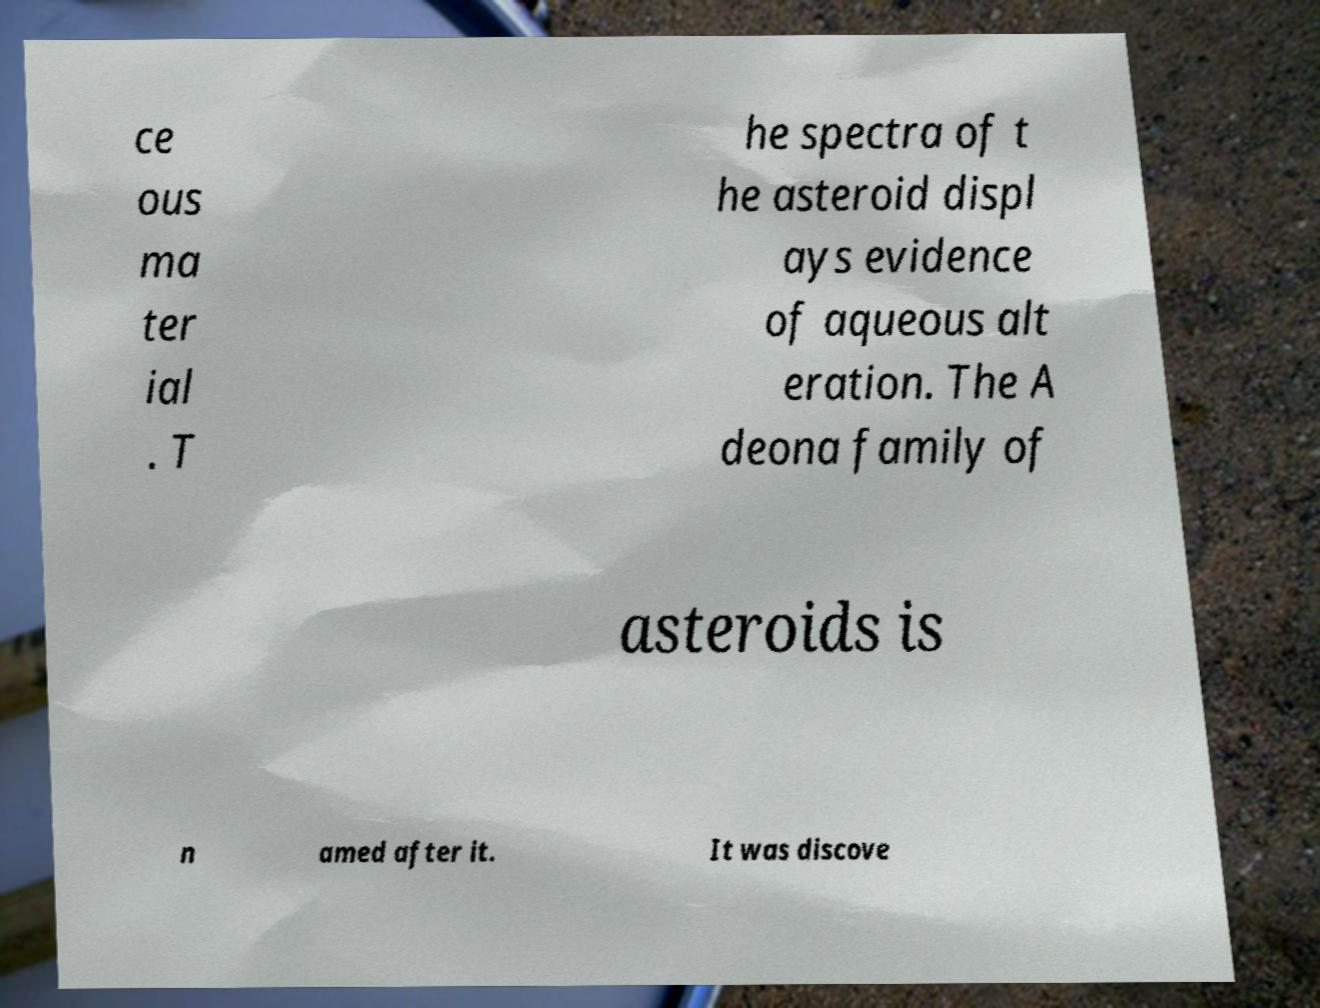Please read and relay the text visible in this image. What does it say? ce ous ma ter ial . T he spectra of t he asteroid displ ays evidence of aqueous alt eration. The A deona family of asteroids is n amed after it. It was discove 